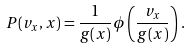<formula> <loc_0><loc_0><loc_500><loc_500>P ( v _ { x } , x ) = \frac { 1 } { g ( x ) } \phi \left ( \frac { v _ { x } } { g ( x ) } \right ) .</formula> 